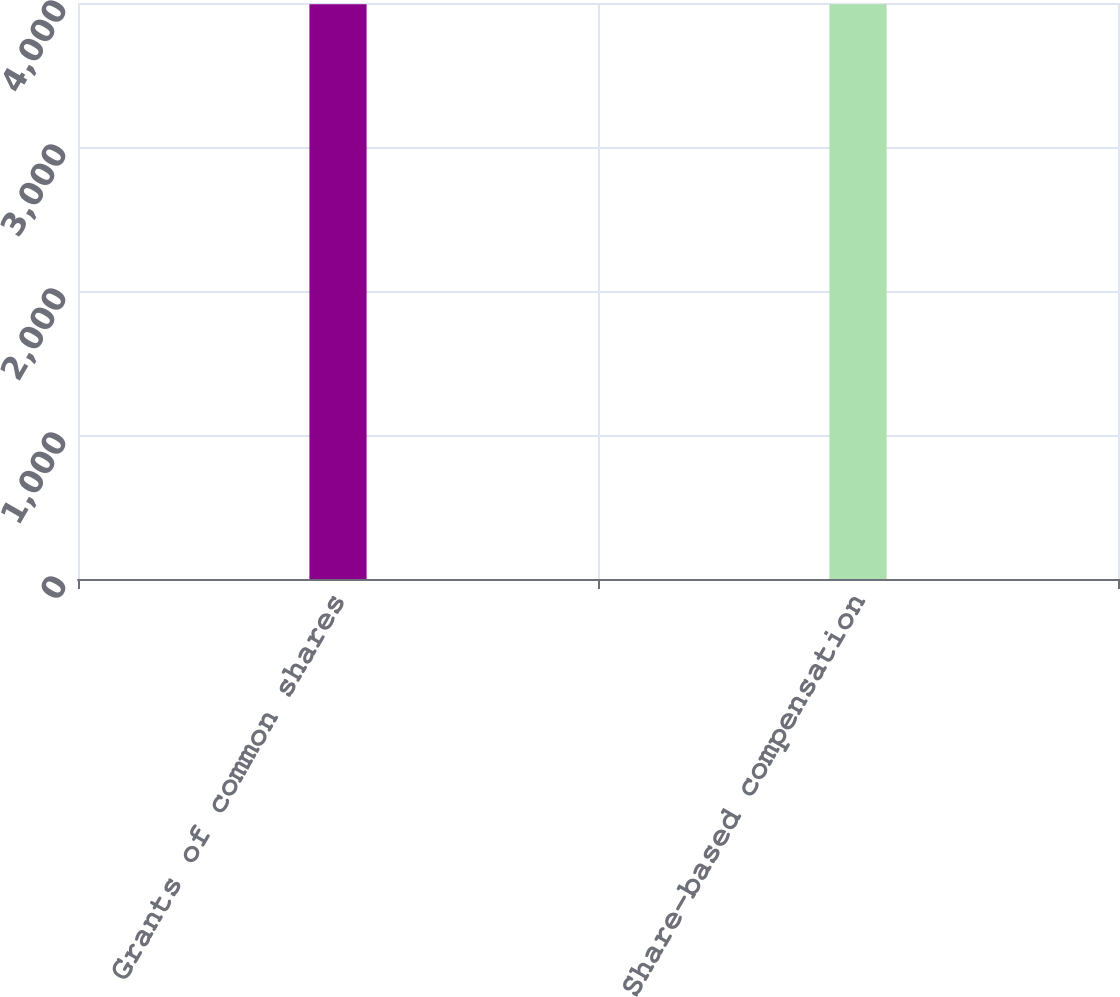Convert chart. <chart><loc_0><loc_0><loc_500><loc_500><bar_chart><fcel>Grants of common shares<fcel>Share-based compensation<nl><fcel>3992<fcel>3992.1<nl></chart> 